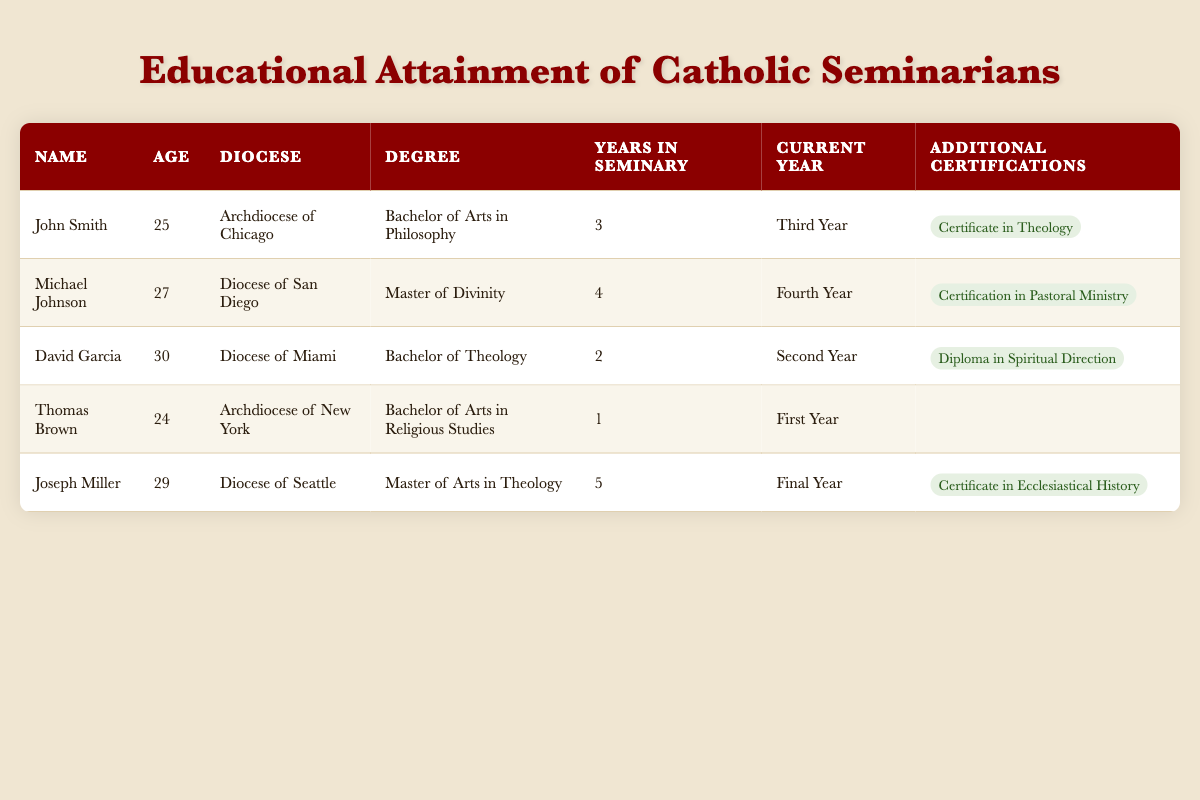What is the degree attained by Michael Johnson? From the table, I can find Michael Johnson in the second row. His corresponding degree is listed as "Master of Divinity."
Answer: Master of Divinity How many years has David Garcia been in the seminary? In the table, David Garcia is found in the third row. The column for "Years in Seminary" shows that he has been in the seminary for 2 years.
Answer: 2 years Is Thomas Brown currently in his final year of seminary? Referring to the table, I see that Thomas Brown is in the fifth row. His "Current Year" is listed as "First Year," which indicates he is not in his final year.
Answer: No Which seminarian has the highest educational attainment level? To determine this, I would look at the degrees listed. The seminarian with the highest educational attainment based on the degrees mentioned is Michael Johnson with a "Master of Divinity."
Answer: Michael Johnson How many seminarians are from the Archdiocese of Chicago and New York combined? Checking the table, John Smith is from the Archdiocese of Chicago and Thomas Brown is from the Archdiocese of New York. Therefore, there are 2 seminarians from these dioceses combined.
Answer: 2 seminarians What is the average age of the seminarians listed? To find the average age, I will sum the ages of all seminarians: (25 + 27 + 30 + 24 + 29) = 135. Since there are 5 seminarians, the average age is 135 / 5 = 27.
Answer: 27 Does Joseph Miller have any additional certifications? In the table, looking at Joseph Miller’s entry, under "Additional Certifications," he has "Certificate in Ecclesiastical History," confirming that he does have additional certifications.
Answer: Yes What is the degree of the seminarian who has been in the seminary for the longest period? From the table, Joseph Miller has been in the seminary for 5 years, which is the longest. His degree is "Master of Arts in Theology."
Answer: Master of Arts in Theology 